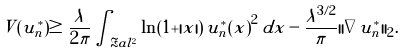<formula> <loc_0><loc_0><loc_500><loc_500>V ( u ^ { * } _ { n } ) \geq \frac { \lambda } { 2 \pi } \int _ { \Re a l ^ { 2 } } \ln ( 1 + | x | ) \, { u ^ { * } _ { n } ( x ) } ^ { 2 } \, d x - \frac { \lambda ^ { 3 / 2 } } { \pi } | | \nabla u ^ { * } _ { n } | | _ { 2 } .</formula> 